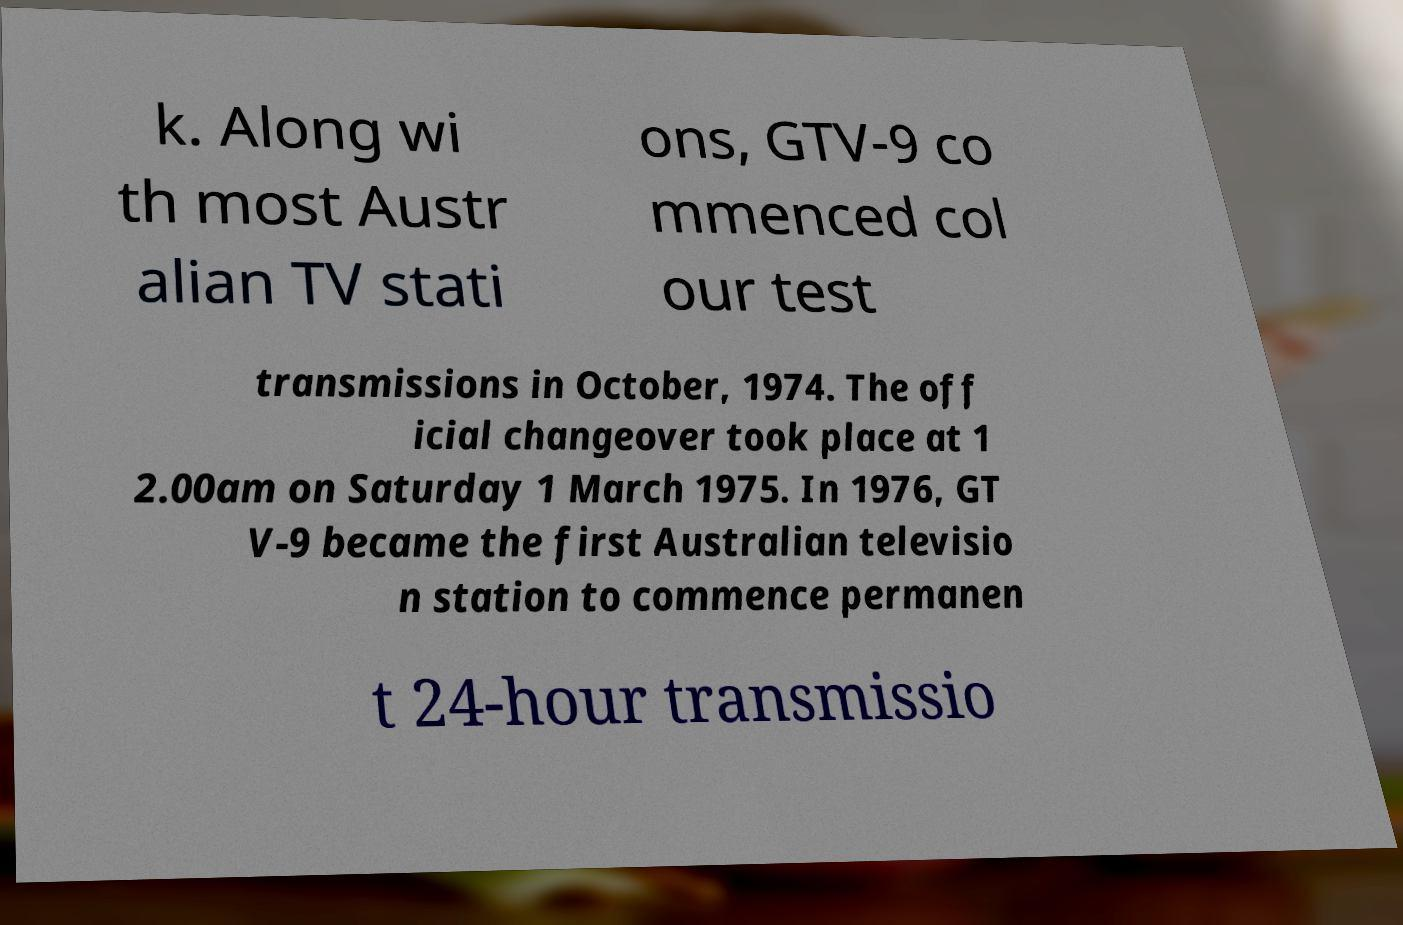Can you accurately transcribe the text from the provided image for me? k. Along wi th most Austr alian TV stati ons, GTV-9 co mmenced col our test transmissions in October, 1974. The off icial changeover took place at 1 2.00am on Saturday 1 March 1975. In 1976, GT V-9 became the first Australian televisio n station to commence permanen t 24-hour transmissio 